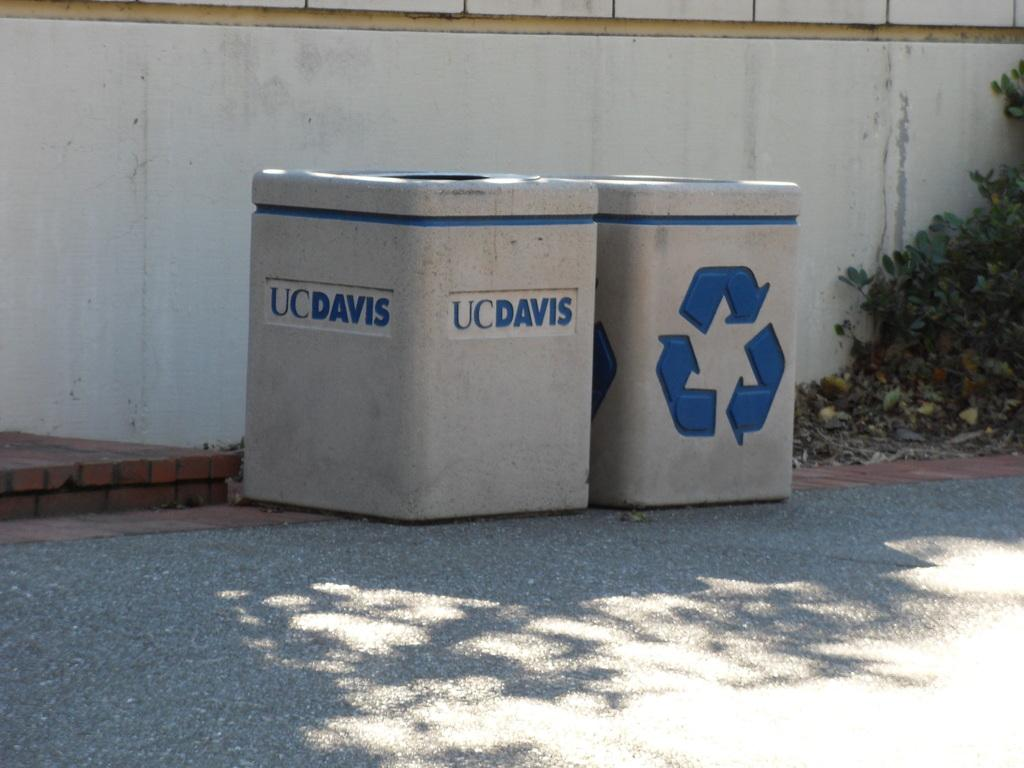<image>
Describe the image concisely. A trash can that belong to UCDavis and a recycling bin is sitting next to it. 